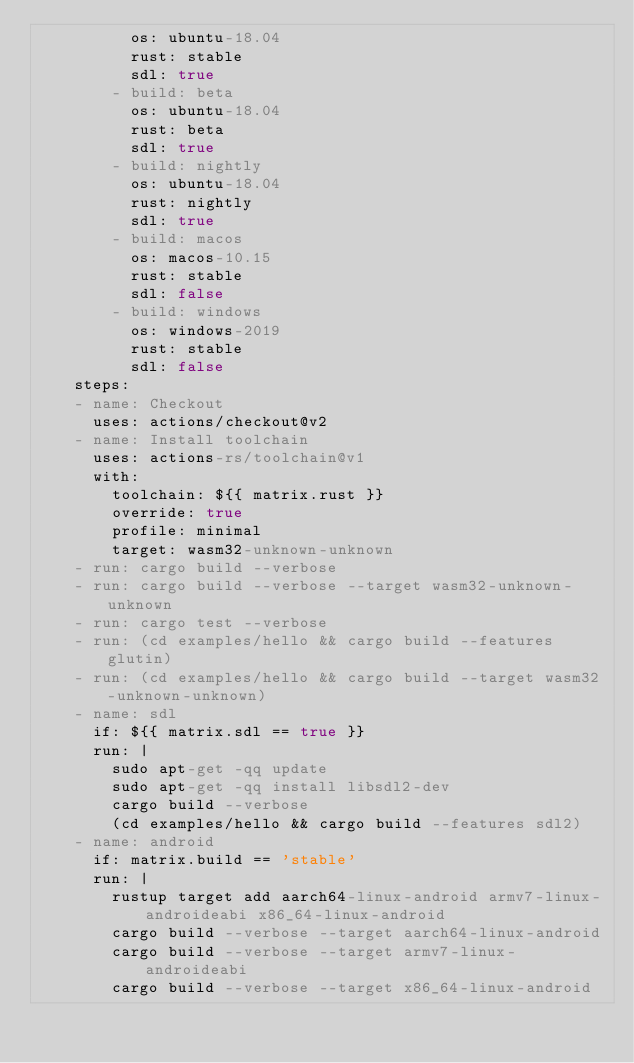<code> <loc_0><loc_0><loc_500><loc_500><_YAML_>          os: ubuntu-18.04
          rust: stable
          sdl: true
        - build: beta
          os: ubuntu-18.04
          rust: beta
          sdl: true
        - build: nightly
          os: ubuntu-18.04
          rust: nightly
          sdl: true
        - build: macos
          os: macos-10.15
          rust: stable
          sdl: false
        - build: windows
          os: windows-2019
          rust: stable
          sdl: false
    steps:
    - name: Checkout
      uses: actions/checkout@v2
    - name: Install toolchain 
      uses: actions-rs/toolchain@v1
      with:
        toolchain: ${{ matrix.rust }}
        override: true
        profile: minimal
        target: wasm32-unknown-unknown
    - run: cargo build --verbose
    - run: cargo build --verbose --target wasm32-unknown-unknown
    - run: cargo test --verbose
    - run: (cd examples/hello && cargo build --features glutin)
    - run: (cd examples/hello && cargo build --target wasm32-unknown-unknown)
    - name: sdl
      if: ${{ matrix.sdl == true }}
      run: |
        sudo apt-get -qq update
        sudo apt-get -qq install libsdl2-dev
        cargo build --verbose
        (cd examples/hello && cargo build --features sdl2)
    - name: android
      if: matrix.build == 'stable'
      run: |
        rustup target add aarch64-linux-android armv7-linux-androideabi x86_64-linux-android
        cargo build --verbose --target aarch64-linux-android
        cargo build --verbose --target armv7-linux-androideabi
        cargo build --verbose --target x86_64-linux-android
</code> 